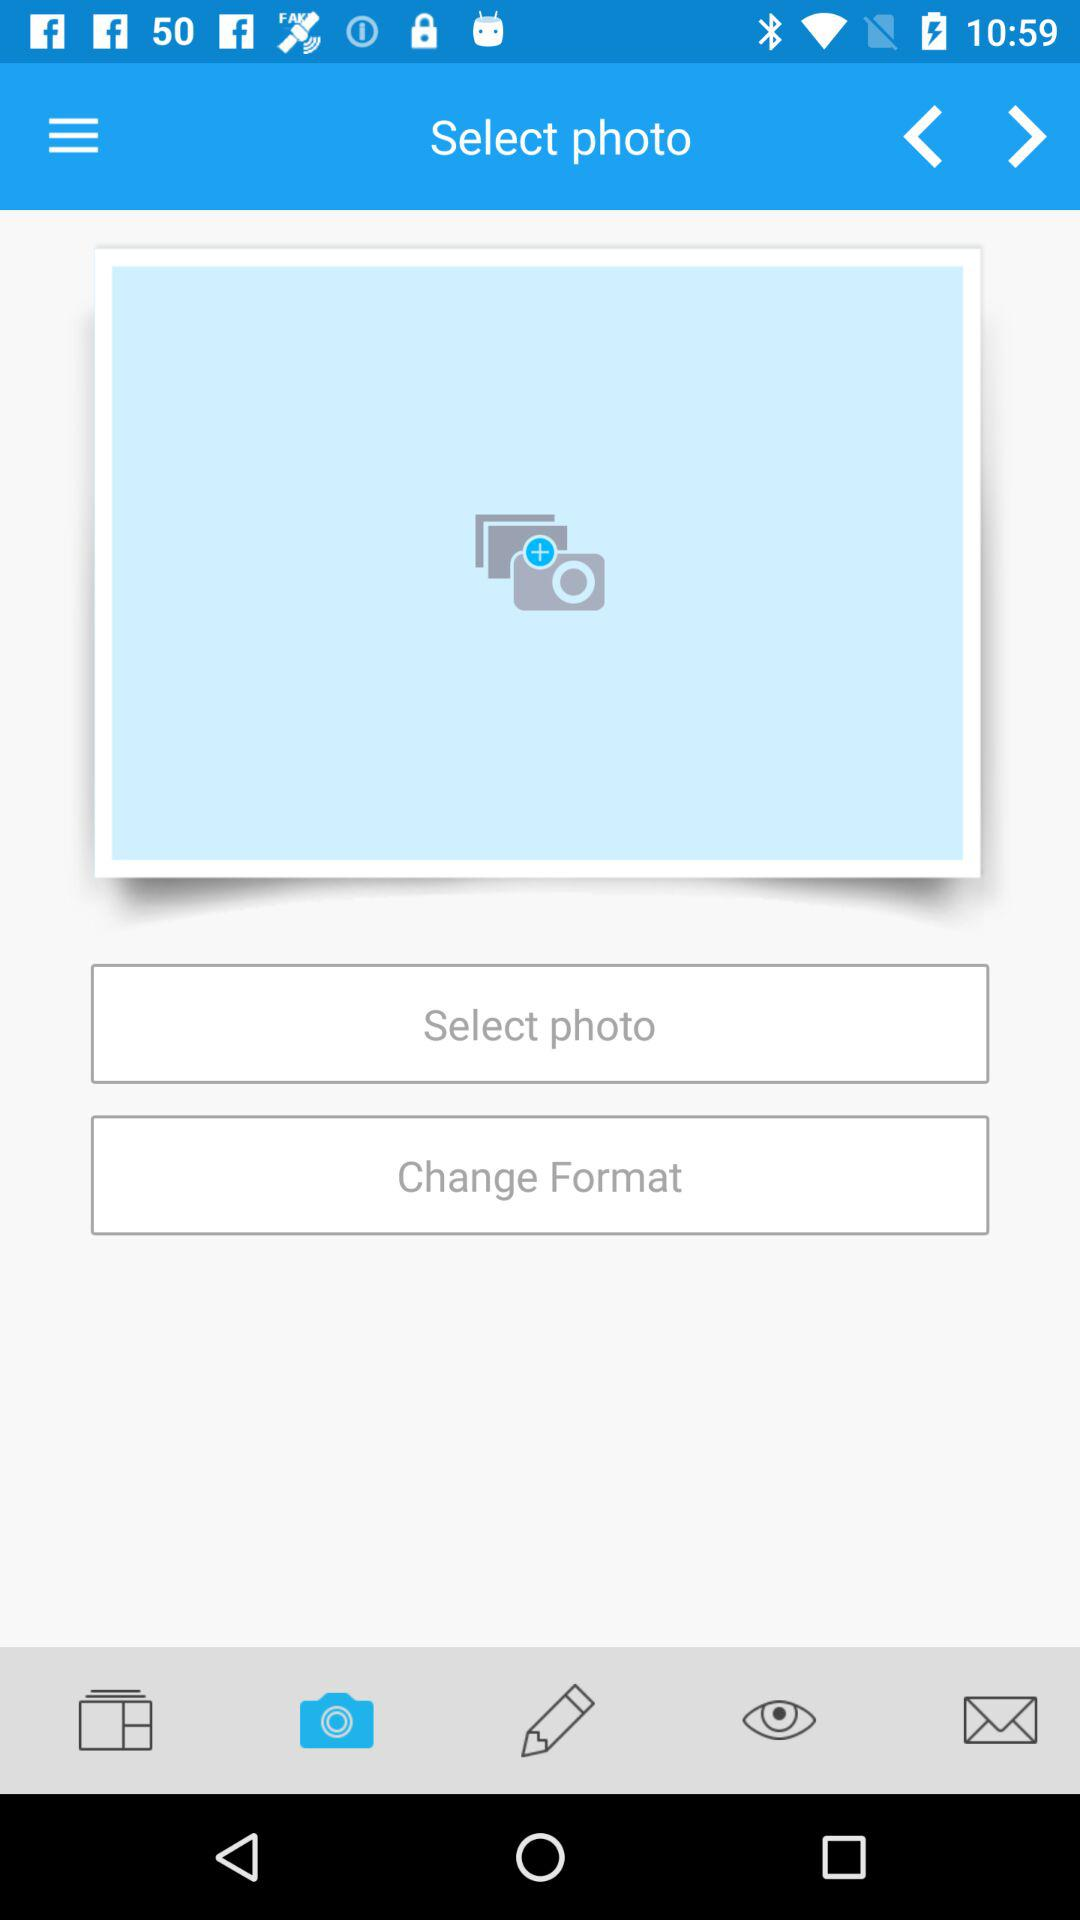Which tab is selected? The selected tab is "Camera". 